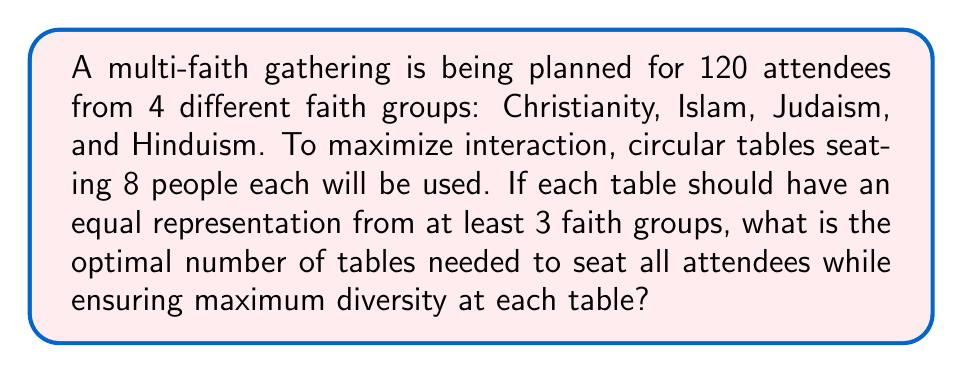Could you help me with this problem? Let's approach this step-by-step:

1) First, we need to calculate the total number of tables required:
   $$\text{Total tables} = \frac{\text{Total attendees}}{\text{Seats per table}} = \frac{120}{8} = 15$$

2) To ensure equal representation from at least 3 faith groups at each table, we need to distribute the attendees as evenly as possible. Let's assume each faith group has an equal number of attendees:
   $$\text{Attendees per faith group} = \frac{120}{4} = 30$$

3) Now, we need to determine how many people from each faith group should be at each table. To maximize diversity, we want 2 people from 3 different faiths and 2 people from the fourth faith at each table:
   $$2 + 2 + 2 + 2 = 8$$

4) With this arrangement, we can calculate how many tables each faith group will be represented at:
   $$\text{Tables per faith group} = \frac{\text{Attendees per faith group}}{\text{Representatives per table}} = \frac{30}{2} = 15$$

5) This matches our total number of tables, confirming that this arrangement is possible and optimal.

6) To verify, let's check if this arrangement accounts for all attendees:
   $$15 \text{ tables} \times 8 \text{ people per table} = 120 \text{ total attendees}$$

Therefore, 15 tables is the optimal number to seat all attendees while ensuring maximum diversity at each table.
Answer: 15 tables 